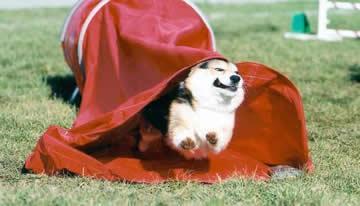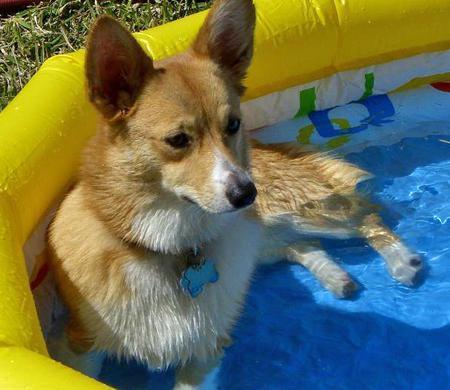The first image is the image on the left, the second image is the image on the right. Given the left and right images, does the statement "The dog in the right image is inside of a small inflatable swimming pool." hold true? Answer yes or no. Yes. The first image is the image on the left, the second image is the image on the right. Evaluate the accuracy of this statement regarding the images: "No less than one dog is in mid air jumping over a hurdle". Is it true? Answer yes or no. No. 